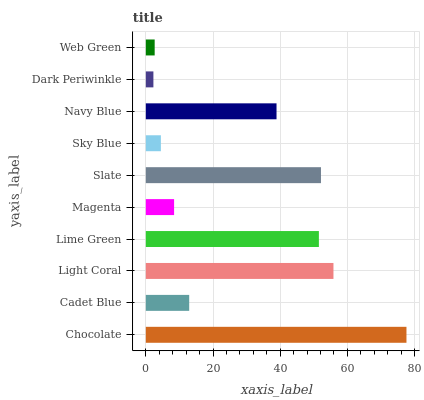Is Dark Periwinkle the minimum?
Answer yes or no. Yes. Is Chocolate the maximum?
Answer yes or no. Yes. Is Cadet Blue the minimum?
Answer yes or no. No. Is Cadet Blue the maximum?
Answer yes or no. No. Is Chocolate greater than Cadet Blue?
Answer yes or no. Yes. Is Cadet Blue less than Chocolate?
Answer yes or no. Yes. Is Cadet Blue greater than Chocolate?
Answer yes or no. No. Is Chocolate less than Cadet Blue?
Answer yes or no. No. Is Navy Blue the high median?
Answer yes or no. Yes. Is Cadet Blue the low median?
Answer yes or no. Yes. Is Light Coral the high median?
Answer yes or no. No. Is Magenta the low median?
Answer yes or no. No. 